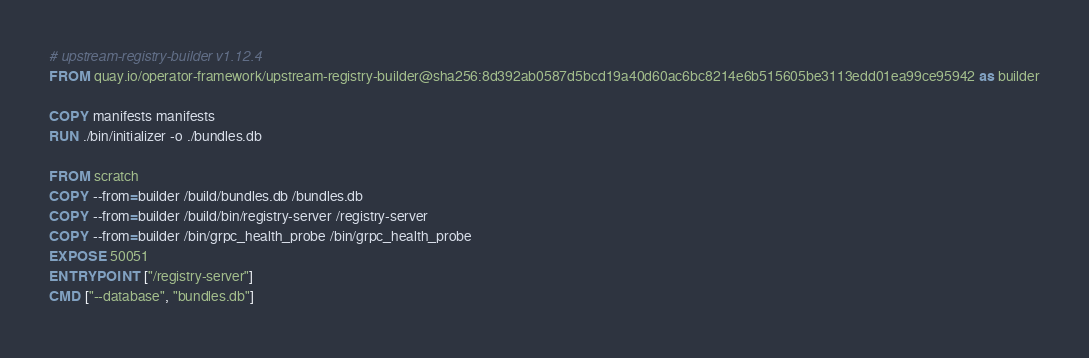<code> <loc_0><loc_0><loc_500><loc_500><_Dockerfile_># upstream-registry-builder v1.12.4
FROM quay.io/operator-framework/upstream-registry-builder@sha256:8d392ab0587d5bcd19a40d60ac6bc8214e6b515605be3113edd01ea99ce95942 as builder

COPY manifests manifests
RUN ./bin/initializer -o ./bundles.db

FROM scratch
COPY --from=builder /build/bundles.db /bundles.db
COPY --from=builder /build/bin/registry-server /registry-server
COPY --from=builder /bin/grpc_health_probe /bin/grpc_health_probe
EXPOSE 50051
ENTRYPOINT ["/registry-server"]
CMD ["--database", "bundles.db"]</code> 